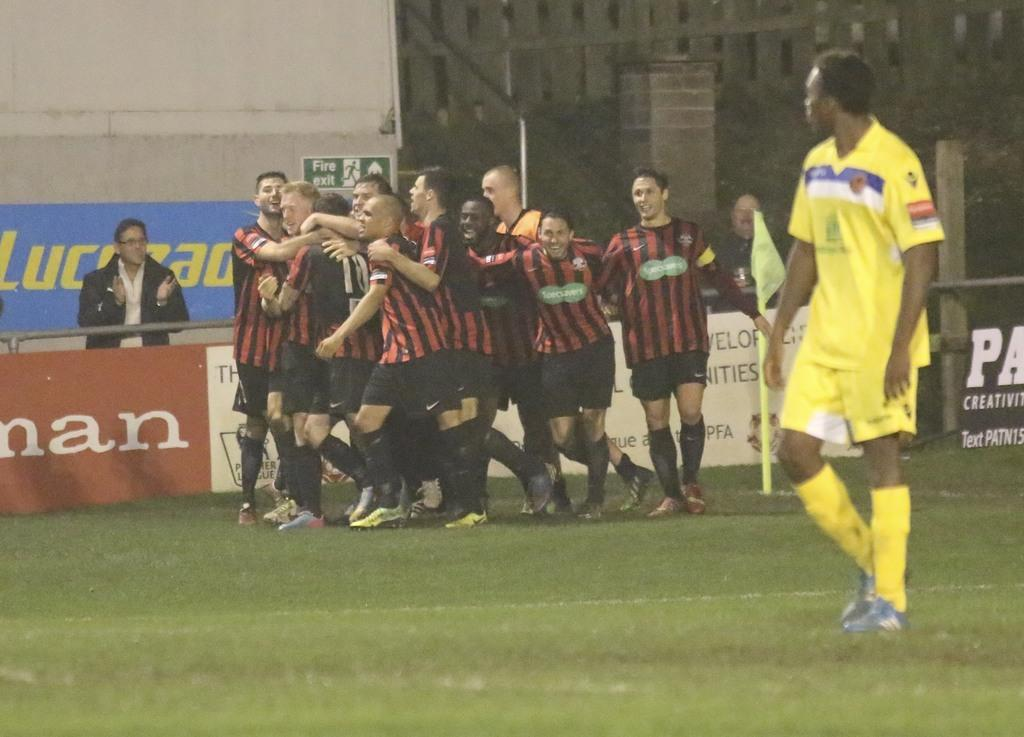<image>
Present a compact description of the photo's key features. An orange banner with man in white letters is on the side of the field. 